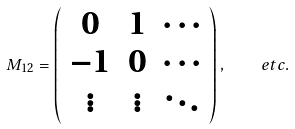<formula> <loc_0><loc_0><loc_500><loc_500>M _ { 1 2 } = \left ( \begin{array} { c c c } 0 & 1 & \cdots \\ - 1 & 0 & \cdots \\ \vdots & \vdots & \ddots \end{array} \right ) , \quad e t c .</formula> 